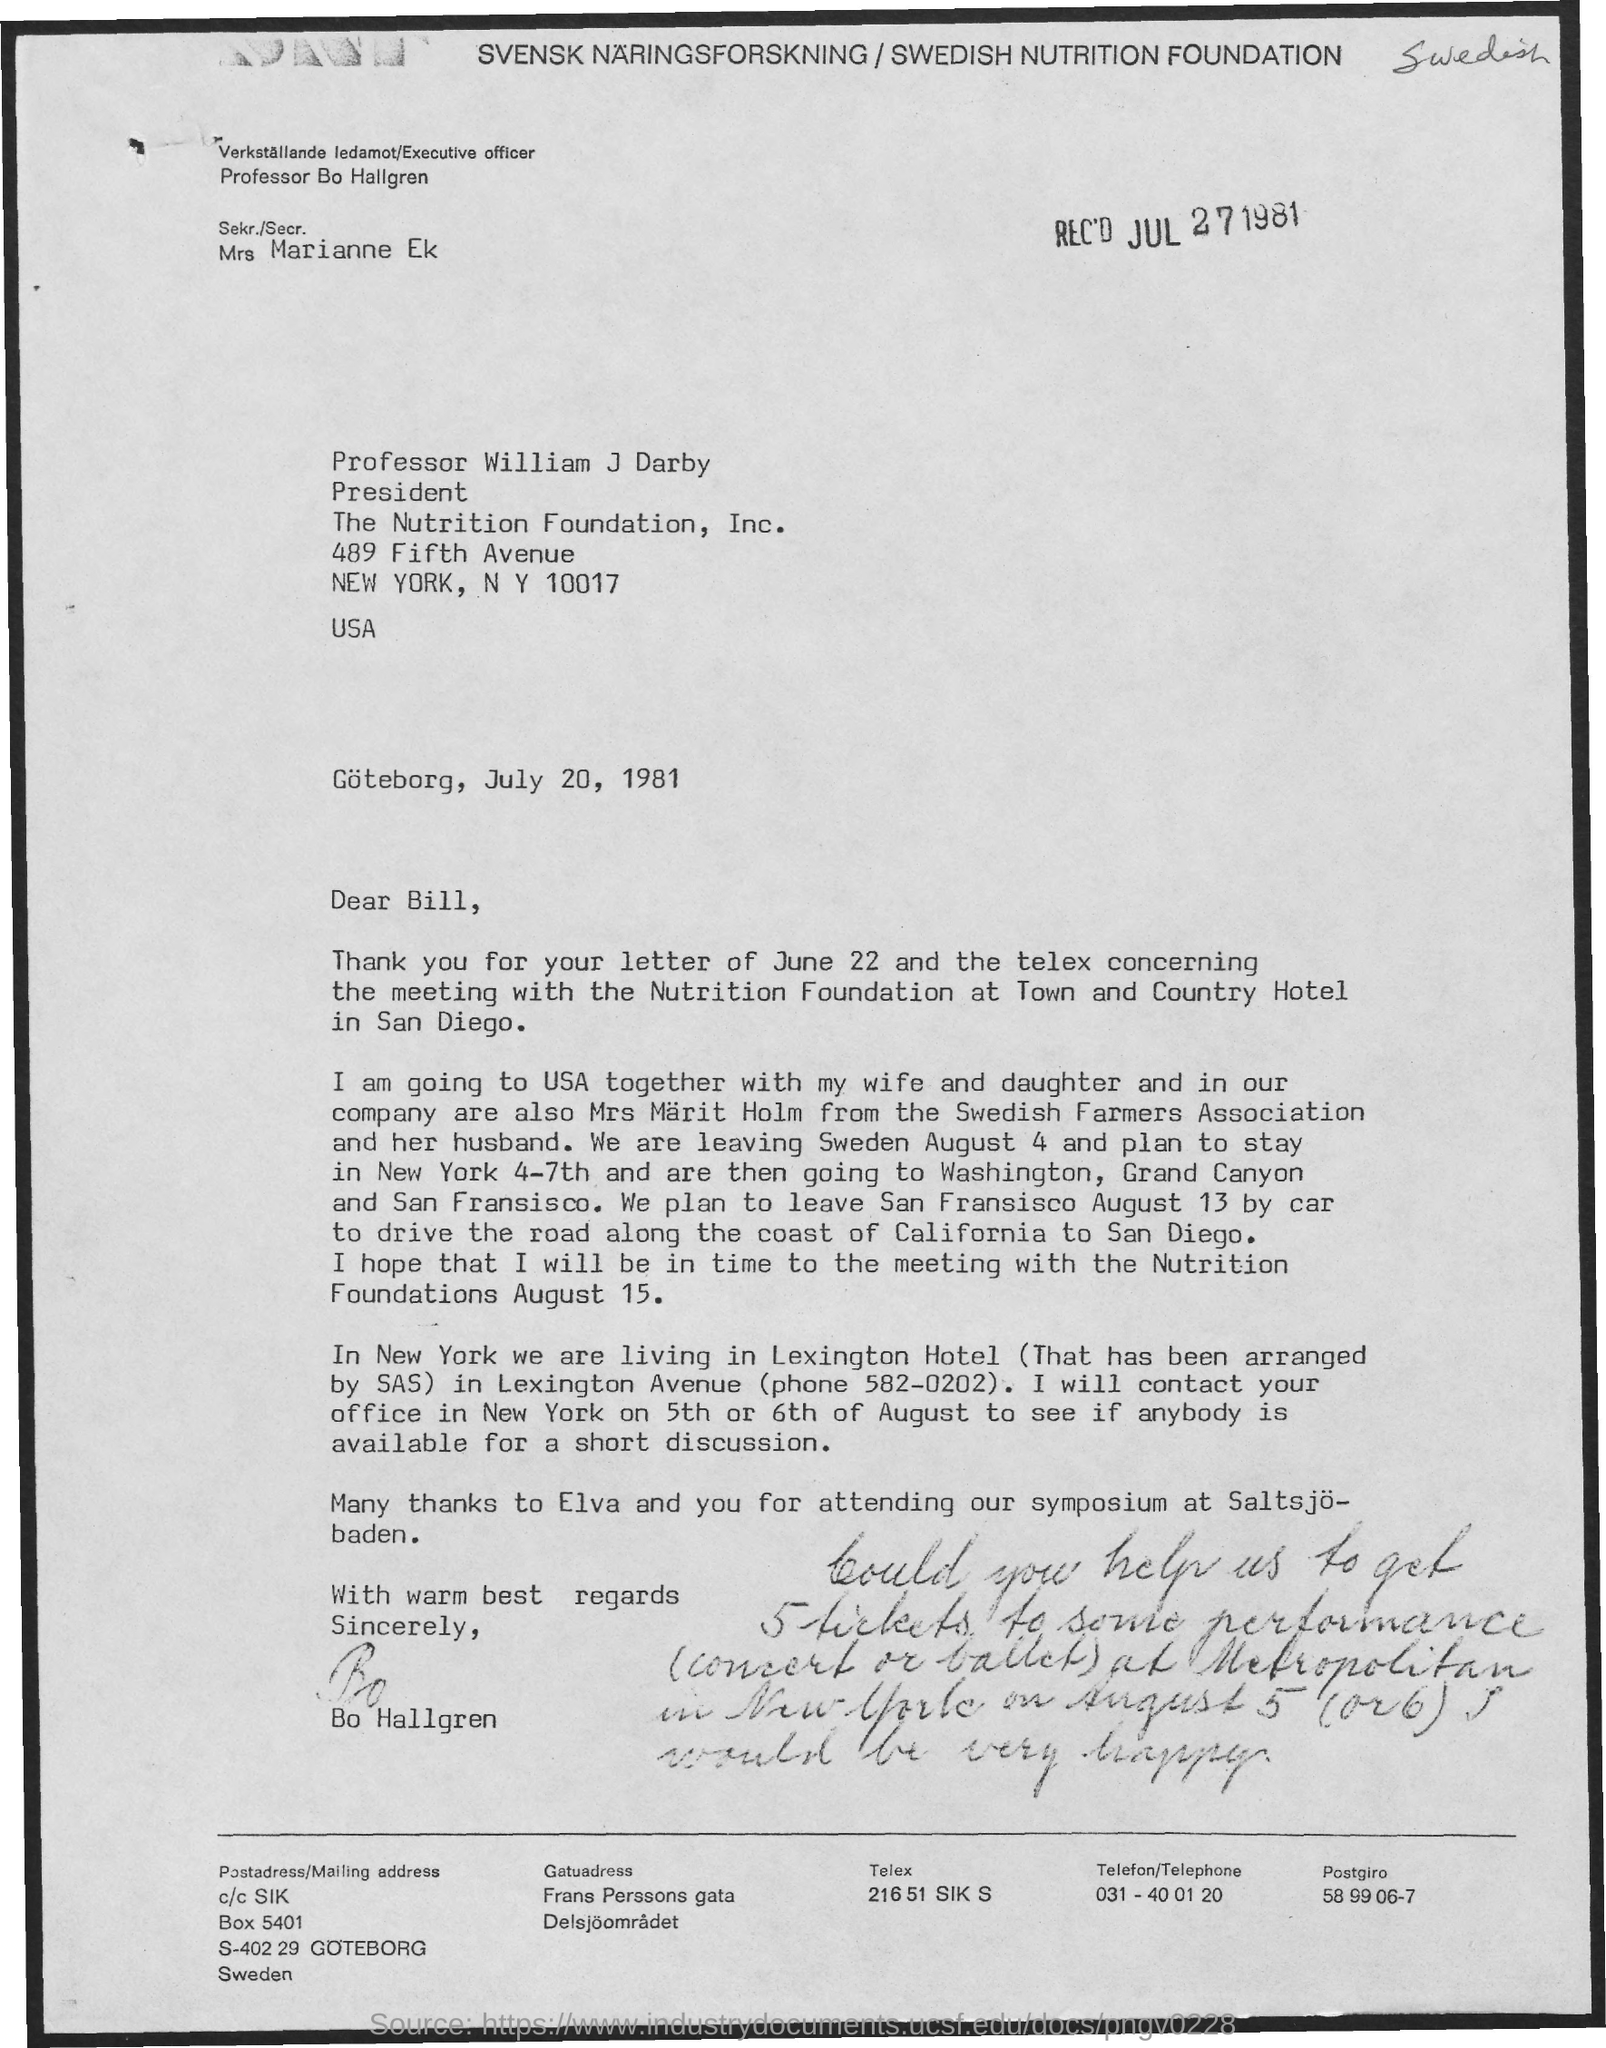Indicate a few pertinent items in this graphic. The letter has been signed by Bo Hallgren. The phone number of Lexington Avenue is 582-0202. The letter was received on July 27, 1981, as indicated by the date specified on the letter. 